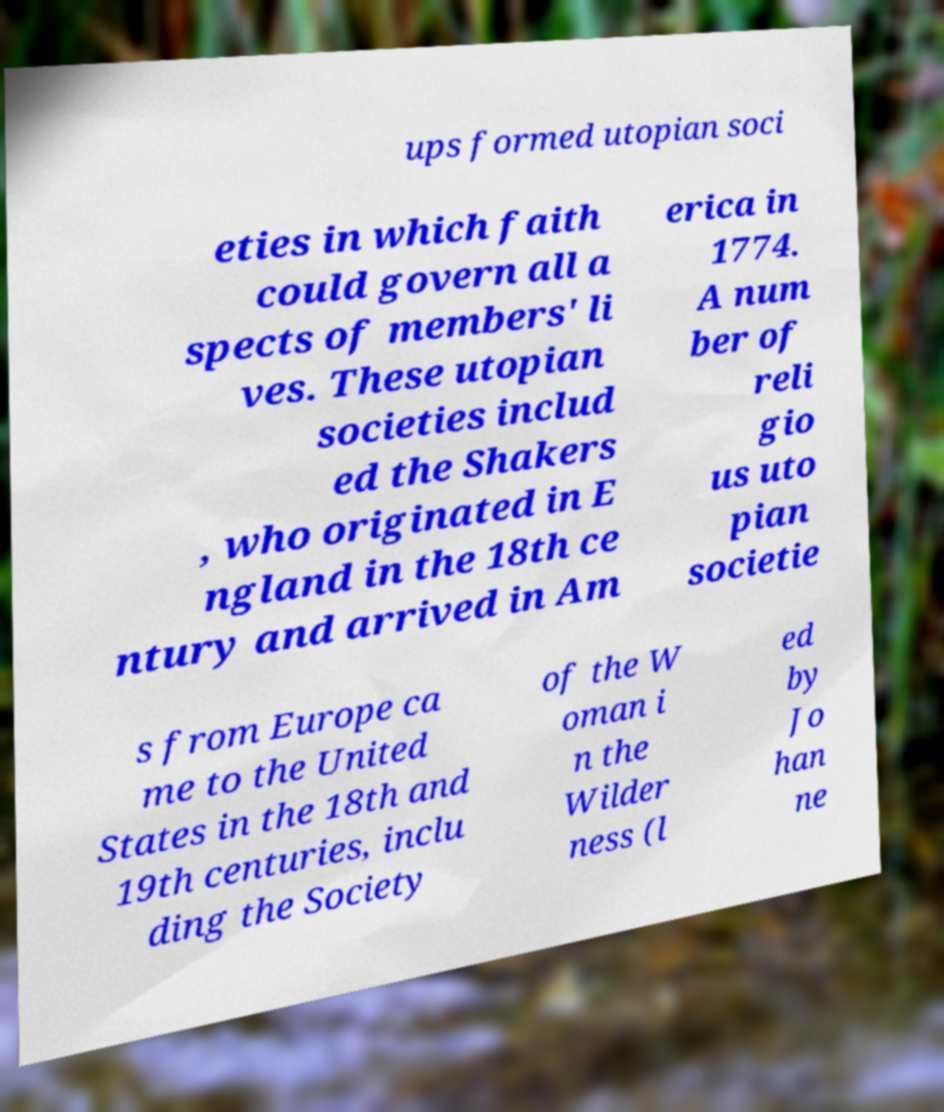Please identify and transcribe the text found in this image. ups formed utopian soci eties in which faith could govern all a spects of members' li ves. These utopian societies includ ed the Shakers , who originated in E ngland in the 18th ce ntury and arrived in Am erica in 1774. A num ber of reli gio us uto pian societie s from Europe ca me to the United States in the 18th and 19th centuries, inclu ding the Society of the W oman i n the Wilder ness (l ed by Jo han ne 